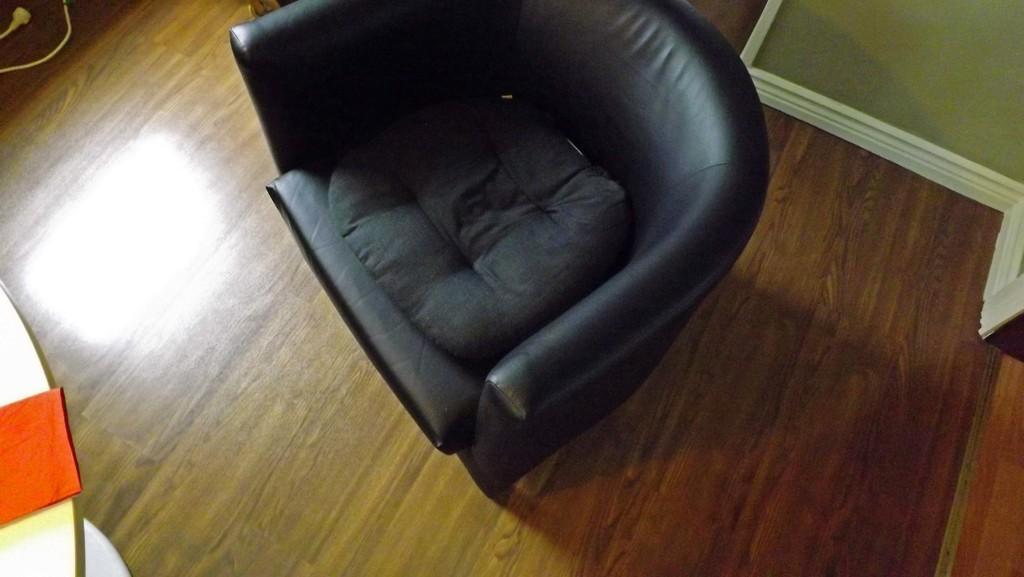Describe this image in one or two sentences. In this image I can see the couch and the couch is in black color, background the wall is in green and white color and I can also see the wire in white color. 